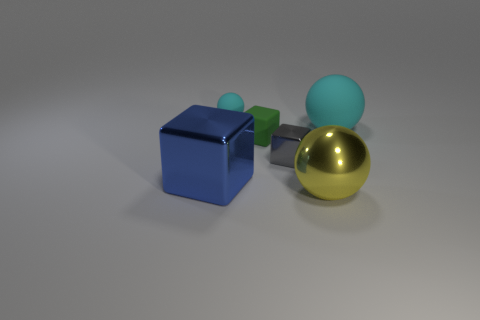Add 2 yellow metallic things. How many objects exist? 8 Add 1 big balls. How many big balls exist? 3 Subtract 0 red cylinders. How many objects are left? 6 Subtract all green rubber cubes. Subtract all shiny blocks. How many objects are left? 3 Add 1 big metal blocks. How many big metal blocks are left? 2 